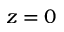Convert formula to latex. <formula><loc_0><loc_0><loc_500><loc_500>z = 0</formula> 